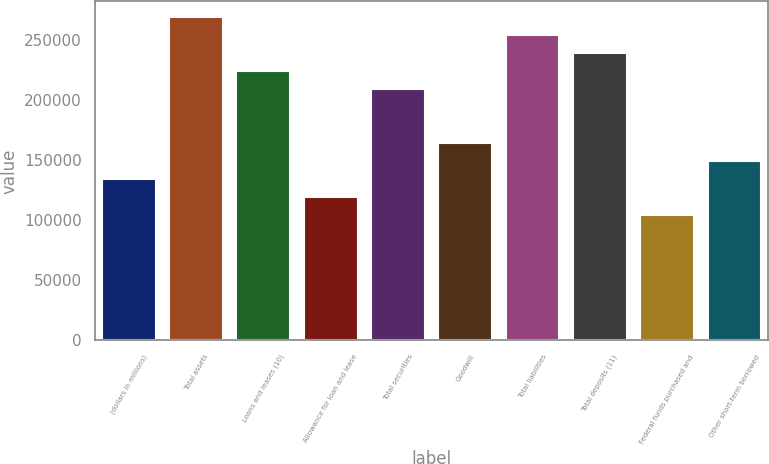Convert chart. <chart><loc_0><loc_0><loc_500><loc_500><bar_chart><fcel>(dollars in millions)<fcel>Total assets<fcel>Loans and leases (10)<fcel>Allowance for loan and lease<fcel>Total securities<fcel>Goodwill<fcel>Total liabilities<fcel>Total deposits (11)<fcel>Federal funds purchased and<fcel>Other short-term borrowed<nl><fcel>134568<fcel>269135<fcel>224279<fcel>119616<fcel>209328<fcel>164472<fcel>254183<fcel>239231<fcel>104664<fcel>149520<nl></chart> 